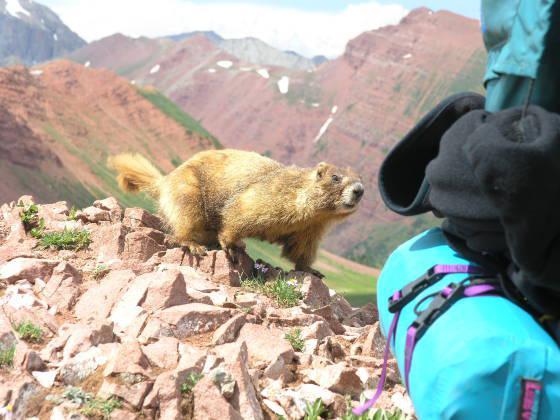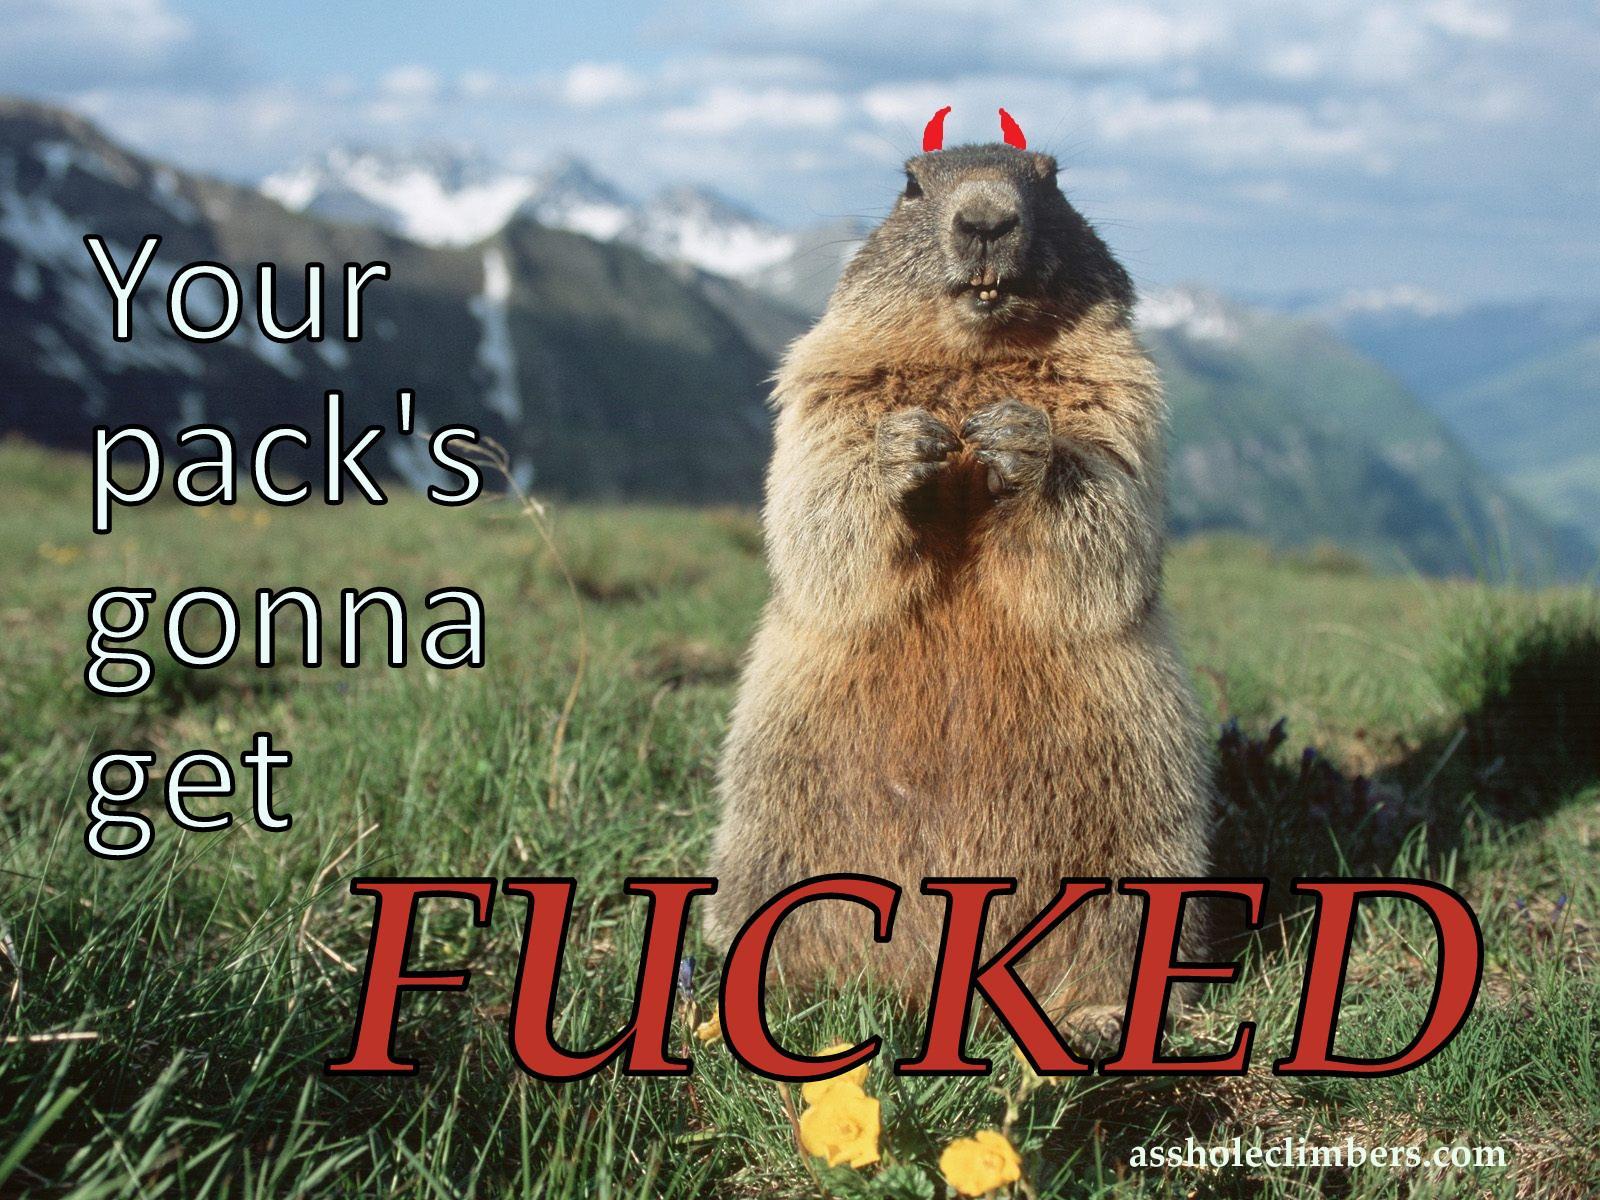The first image is the image on the left, the second image is the image on the right. Examine the images to the left and right. Is the description "At least two animals are very close to each other." accurate? Answer yes or no. No. The first image is the image on the left, the second image is the image on the right. For the images shown, is this caption "There are at least three rodents." true? Answer yes or no. No. 